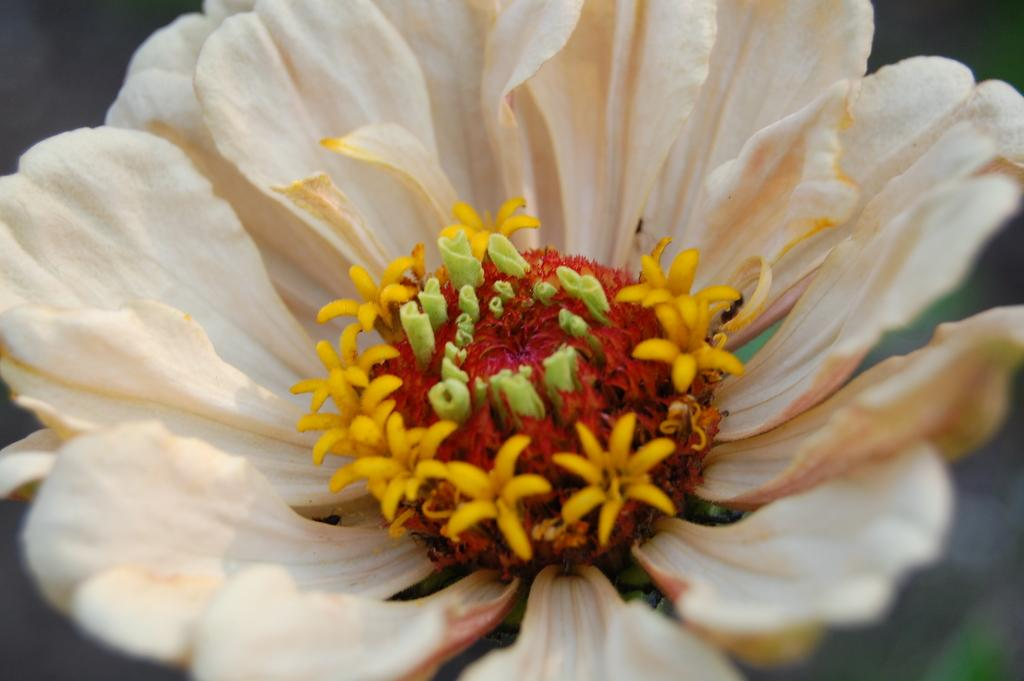What type of flower is in the image? There is a white flower in the image. What color are the petals of the flower? The flower has white petals. What type of paint is used to color the stocking in the image? There is no stocking or paint present in the image; it only features a white flower with white petals. 